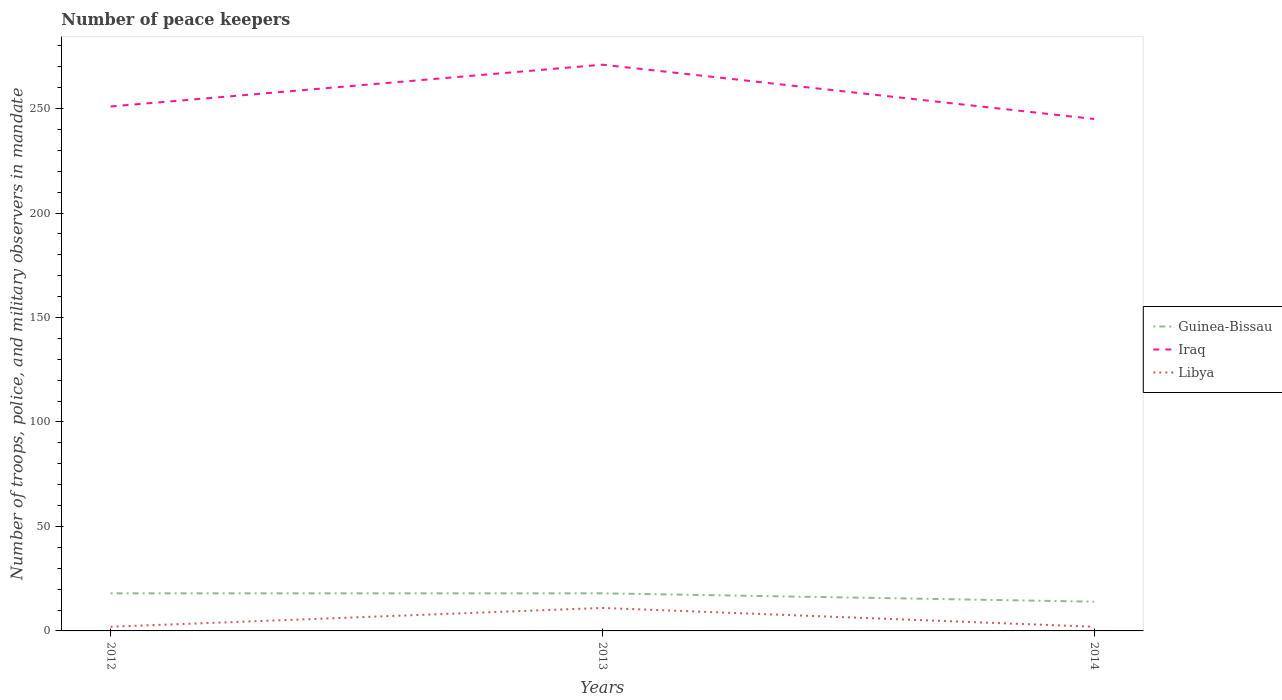How many different coloured lines are there?
Provide a succinct answer. 3. Is the number of lines equal to the number of legend labels?
Offer a terse response. Yes. Across all years, what is the maximum number of peace keepers in in Iraq?
Your answer should be compact. 245. In which year was the number of peace keepers in in Iraq maximum?
Provide a short and direct response. 2014. What is the difference between the highest and the second highest number of peace keepers in in Guinea-Bissau?
Give a very brief answer. 4. Is the number of peace keepers in in Guinea-Bissau strictly greater than the number of peace keepers in in Iraq over the years?
Your response must be concise. Yes. How many lines are there?
Your answer should be very brief. 3. Are the values on the major ticks of Y-axis written in scientific E-notation?
Offer a terse response. No. Does the graph contain grids?
Your answer should be compact. No. Where does the legend appear in the graph?
Provide a succinct answer. Center right. How many legend labels are there?
Your answer should be very brief. 3. How are the legend labels stacked?
Offer a terse response. Vertical. What is the title of the graph?
Offer a terse response. Number of peace keepers. Does "Luxembourg" appear as one of the legend labels in the graph?
Provide a succinct answer. No. What is the label or title of the X-axis?
Offer a terse response. Years. What is the label or title of the Y-axis?
Give a very brief answer. Number of troops, police, and military observers in mandate. What is the Number of troops, police, and military observers in mandate in Iraq in 2012?
Give a very brief answer. 251. What is the Number of troops, police, and military observers in mandate of Guinea-Bissau in 2013?
Offer a very short reply. 18. What is the Number of troops, police, and military observers in mandate of Iraq in 2013?
Keep it short and to the point. 271. What is the Number of troops, police, and military observers in mandate in Libya in 2013?
Offer a terse response. 11. What is the Number of troops, police, and military observers in mandate in Guinea-Bissau in 2014?
Offer a very short reply. 14. What is the Number of troops, police, and military observers in mandate of Iraq in 2014?
Give a very brief answer. 245. What is the Number of troops, police, and military observers in mandate in Libya in 2014?
Your answer should be very brief. 2. Across all years, what is the maximum Number of troops, police, and military observers in mandate in Iraq?
Make the answer very short. 271. Across all years, what is the minimum Number of troops, police, and military observers in mandate in Guinea-Bissau?
Offer a terse response. 14. Across all years, what is the minimum Number of troops, police, and military observers in mandate in Iraq?
Keep it short and to the point. 245. Across all years, what is the minimum Number of troops, police, and military observers in mandate of Libya?
Ensure brevity in your answer.  2. What is the total Number of troops, police, and military observers in mandate of Iraq in the graph?
Your response must be concise. 767. What is the difference between the Number of troops, police, and military observers in mandate of Libya in 2012 and that in 2013?
Provide a short and direct response. -9. What is the difference between the Number of troops, police, and military observers in mandate in Guinea-Bissau in 2012 and that in 2014?
Offer a very short reply. 4. What is the difference between the Number of troops, police, and military observers in mandate of Iraq in 2012 and that in 2014?
Your answer should be compact. 6. What is the difference between the Number of troops, police, and military observers in mandate of Libya in 2012 and that in 2014?
Give a very brief answer. 0. What is the difference between the Number of troops, police, and military observers in mandate in Iraq in 2013 and that in 2014?
Ensure brevity in your answer.  26. What is the difference between the Number of troops, police, and military observers in mandate of Guinea-Bissau in 2012 and the Number of troops, police, and military observers in mandate of Iraq in 2013?
Your answer should be compact. -253. What is the difference between the Number of troops, police, and military observers in mandate of Guinea-Bissau in 2012 and the Number of troops, police, and military observers in mandate of Libya in 2013?
Offer a very short reply. 7. What is the difference between the Number of troops, police, and military observers in mandate in Iraq in 2012 and the Number of troops, police, and military observers in mandate in Libya in 2013?
Offer a terse response. 240. What is the difference between the Number of troops, police, and military observers in mandate of Guinea-Bissau in 2012 and the Number of troops, police, and military observers in mandate of Iraq in 2014?
Your answer should be compact. -227. What is the difference between the Number of troops, police, and military observers in mandate of Guinea-Bissau in 2012 and the Number of troops, police, and military observers in mandate of Libya in 2014?
Give a very brief answer. 16. What is the difference between the Number of troops, police, and military observers in mandate of Iraq in 2012 and the Number of troops, police, and military observers in mandate of Libya in 2014?
Offer a terse response. 249. What is the difference between the Number of troops, police, and military observers in mandate in Guinea-Bissau in 2013 and the Number of troops, police, and military observers in mandate in Iraq in 2014?
Keep it short and to the point. -227. What is the difference between the Number of troops, police, and military observers in mandate of Guinea-Bissau in 2013 and the Number of troops, police, and military observers in mandate of Libya in 2014?
Offer a terse response. 16. What is the difference between the Number of troops, police, and military observers in mandate in Iraq in 2013 and the Number of troops, police, and military observers in mandate in Libya in 2014?
Provide a short and direct response. 269. What is the average Number of troops, police, and military observers in mandate in Guinea-Bissau per year?
Make the answer very short. 16.67. What is the average Number of troops, police, and military observers in mandate in Iraq per year?
Your response must be concise. 255.67. In the year 2012, what is the difference between the Number of troops, police, and military observers in mandate in Guinea-Bissau and Number of troops, police, and military observers in mandate in Iraq?
Give a very brief answer. -233. In the year 2012, what is the difference between the Number of troops, police, and military observers in mandate in Iraq and Number of troops, police, and military observers in mandate in Libya?
Provide a succinct answer. 249. In the year 2013, what is the difference between the Number of troops, police, and military observers in mandate in Guinea-Bissau and Number of troops, police, and military observers in mandate in Iraq?
Your response must be concise. -253. In the year 2013, what is the difference between the Number of troops, police, and military observers in mandate of Guinea-Bissau and Number of troops, police, and military observers in mandate of Libya?
Make the answer very short. 7. In the year 2013, what is the difference between the Number of troops, police, and military observers in mandate of Iraq and Number of troops, police, and military observers in mandate of Libya?
Offer a very short reply. 260. In the year 2014, what is the difference between the Number of troops, police, and military observers in mandate in Guinea-Bissau and Number of troops, police, and military observers in mandate in Iraq?
Offer a very short reply. -231. In the year 2014, what is the difference between the Number of troops, police, and military observers in mandate of Iraq and Number of troops, police, and military observers in mandate of Libya?
Your answer should be compact. 243. What is the ratio of the Number of troops, police, and military observers in mandate of Guinea-Bissau in 2012 to that in 2013?
Your answer should be very brief. 1. What is the ratio of the Number of troops, police, and military observers in mandate in Iraq in 2012 to that in 2013?
Your response must be concise. 0.93. What is the ratio of the Number of troops, police, and military observers in mandate in Libya in 2012 to that in 2013?
Offer a very short reply. 0.18. What is the ratio of the Number of troops, police, and military observers in mandate in Guinea-Bissau in 2012 to that in 2014?
Ensure brevity in your answer.  1.29. What is the ratio of the Number of troops, police, and military observers in mandate of Iraq in 2012 to that in 2014?
Give a very brief answer. 1.02. What is the ratio of the Number of troops, police, and military observers in mandate in Libya in 2012 to that in 2014?
Provide a succinct answer. 1. What is the ratio of the Number of troops, police, and military observers in mandate in Guinea-Bissau in 2013 to that in 2014?
Provide a short and direct response. 1.29. What is the ratio of the Number of troops, police, and military observers in mandate of Iraq in 2013 to that in 2014?
Your answer should be compact. 1.11. What is the ratio of the Number of troops, police, and military observers in mandate of Libya in 2013 to that in 2014?
Offer a terse response. 5.5. What is the difference between the highest and the second highest Number of troops, police, and military observers in mandate in Guinea-Bissau?
Make the answer very short. 0. What is the difference between the highest and the second highest Number of troops, police, and military observers in mandate of Iraq?
Offer a terse response. 20. 